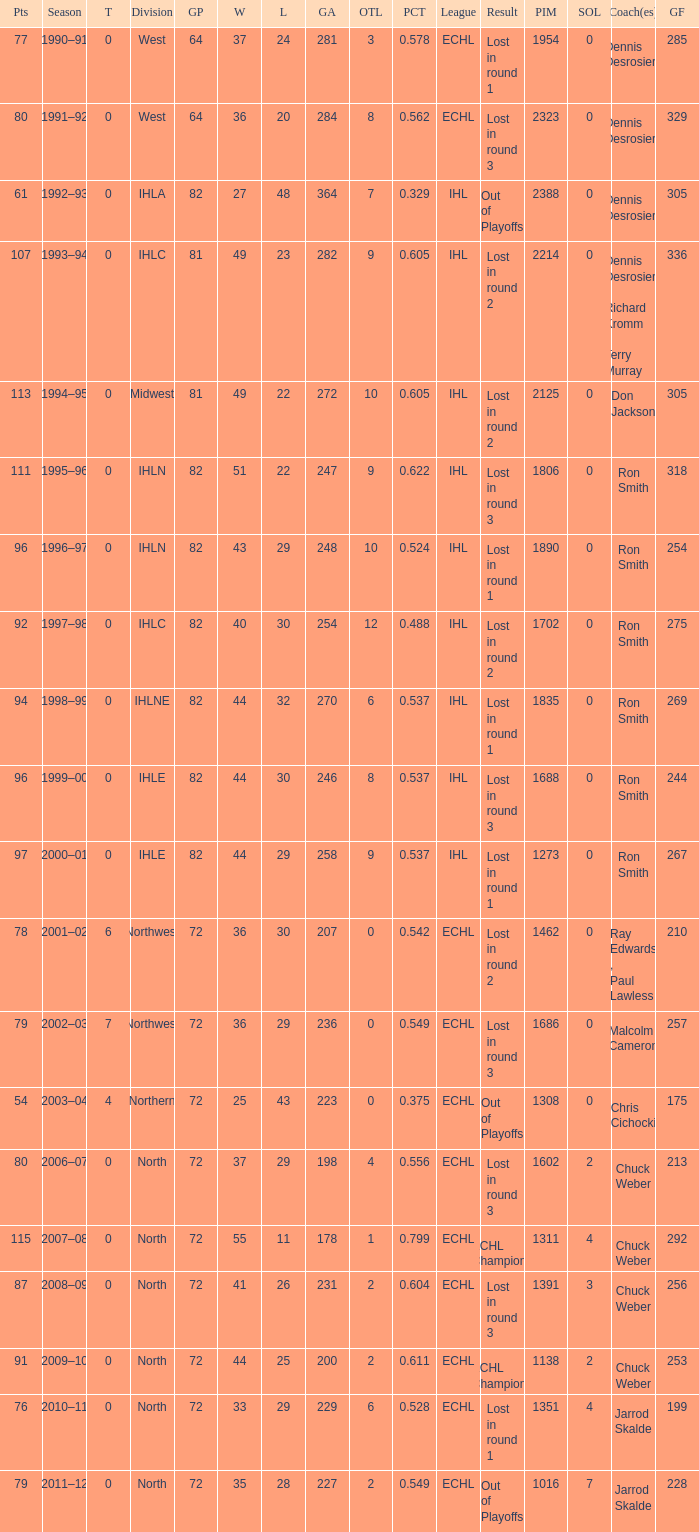Would you mind parsing the complete table? {'header': ['Pts', 'Season', 'T', 'Division', 'GP', 'W', 'L', 'GA', 'OTL', 'PCT', 'League', 'Result', 'PIM', 'SOL', 'Coach(es)', 'GF'], 'rows': [['77', '1990–91', '0', 'West', '64', '37', '24', '281', '3', '0.578', 'ECHL', 'Lost in round 1', '1954', '0', 'Dennis Desrosiers', '285'], ['80', '1991–92', '0', 'West', '64', '36', '20', '284', '8', '0.562', 'ECHL', 'Lost in round 3', '2323', '0', 'Dennis Desrosiers', '329'], ['61', '1992–93', '0', 'IHLA', '82', '27', '48', '364', '7', '0.329', 'IHL', 'Out of Playoffs', '2388', '0', 'Dennis Desrosiers', '305'], ['107', '1993–94', '0', 'IHLC', '81', '49', '23', '282', '9', '0.605', 'IHL', 'Lost in round 2', '2214', '0', 'Dennis Desrosiers , Richard Kromm , Terry Murray', '336'], ['113', '1994–95', '0', 'Midwest', '81', '49', '22', '272', '10', '0.605', 'IHL', 'Lost in round 2', '2125', '0', 'Don Jackson', '305'], ['111', '1995–96', '0', 'IHLN', '82', '51', '22', '247', '9', '0.622', 'IHL', 'Lost in round 3', '1806', '0', 'Ron Smith', '318'], ['96', '1996–97', '0', 'IHLN', '82', '43', '29', '248', '10', '0.524', 'IHL', 'Lost in round 1', '1890', '0', 'Ron Smith', '254'], ['92', '1997–98', '0', 'IHLC', '82', '40', '30', '254', '12', '0.488', 'IHL', 'Lost in round 2', '1702', '0', 'Ron Smith', '275'], ['94', '1998–99', '0', 'IHLNE', '82', '44', '32', '270', '6', '0.537', 'IHL', 'Lost in round 1', '1835', '0', 'Ron Smith', '269'], ['96', '1999–00', '0', 'IHLE', '82', '44', '30', '246', '8', '0.537', 'IHL', 'Lost in round 3', '1688', '0', 'Ron Smith', '244'], ['97', '2000–01', '0', 'IHLE', '82', '44', '29', '258', '9', '0.537', 'IHL', 'Lost in round 1', '1273', '0', 'Ron Smith', '267'], ['78', '2001–02', '6', 'Northwest', '72', '36', '30', '207', '0', '0.542', 'ECHL', 'Lost in round 2', '1462', '0', 'Ray Edwards , Paul Lawless', '210'], ['79', '2002–03', '7', 'Northwest', '72', '36', '29', '236', '0', '0.549', 'ECHL', 'Lost in round 3', '1686', '0', 'Malcolm Cameron', '257'], ['54', '2003–04', '4', 'Northern', '72', '25', '43', '223', '0', '0.375', 'ECHL', 'Out of Playoffs', '1308', '0', 'Chris Cichocki', '175'], ['80', '2006–07', '0', 'North', '72', '37', '29', '198', '4', '0.556', 'ECHL', 'Lost in round 3', '1602', '2', 'Chuck Weber', '213'], ['115', '2007–08', '0', 'North', '72', '55', '11', '178', '1', '0.799', 'ECHL', 'ECHL Champions', '1311', '4', 'Chuck Weber', '292'], ['87', '2008–09', '0', 'North', '72', '41', '26', '231', '2', '0.604', 'ECHL', 'Lost in round 3', '1391', '3', 'Chuck Weber', '256'], ['91', '2009–10', '0', 'North', '72', '44', '25', '200', '2', '0.611', 'ECHL', 'ECHL Champions', '1138', '2', 'Chuck Weber', '253'], ['76', '2010–11', '0', 'North', '72', '33', '29', '229', '6', '0.528', 'ECHL', 'Lost in round 1', '1351', '4', 'Jarrod Skalde', '199'], ['79', '2011–12', '0', 'North', '72', '35', '28', '227', '2', '0.549', 'ECHL', 'Out of Playoffs', '1016', '7', 'Jarrod Skalde', '228']]} What was the maximum OTL if L is 28? 2.0. 